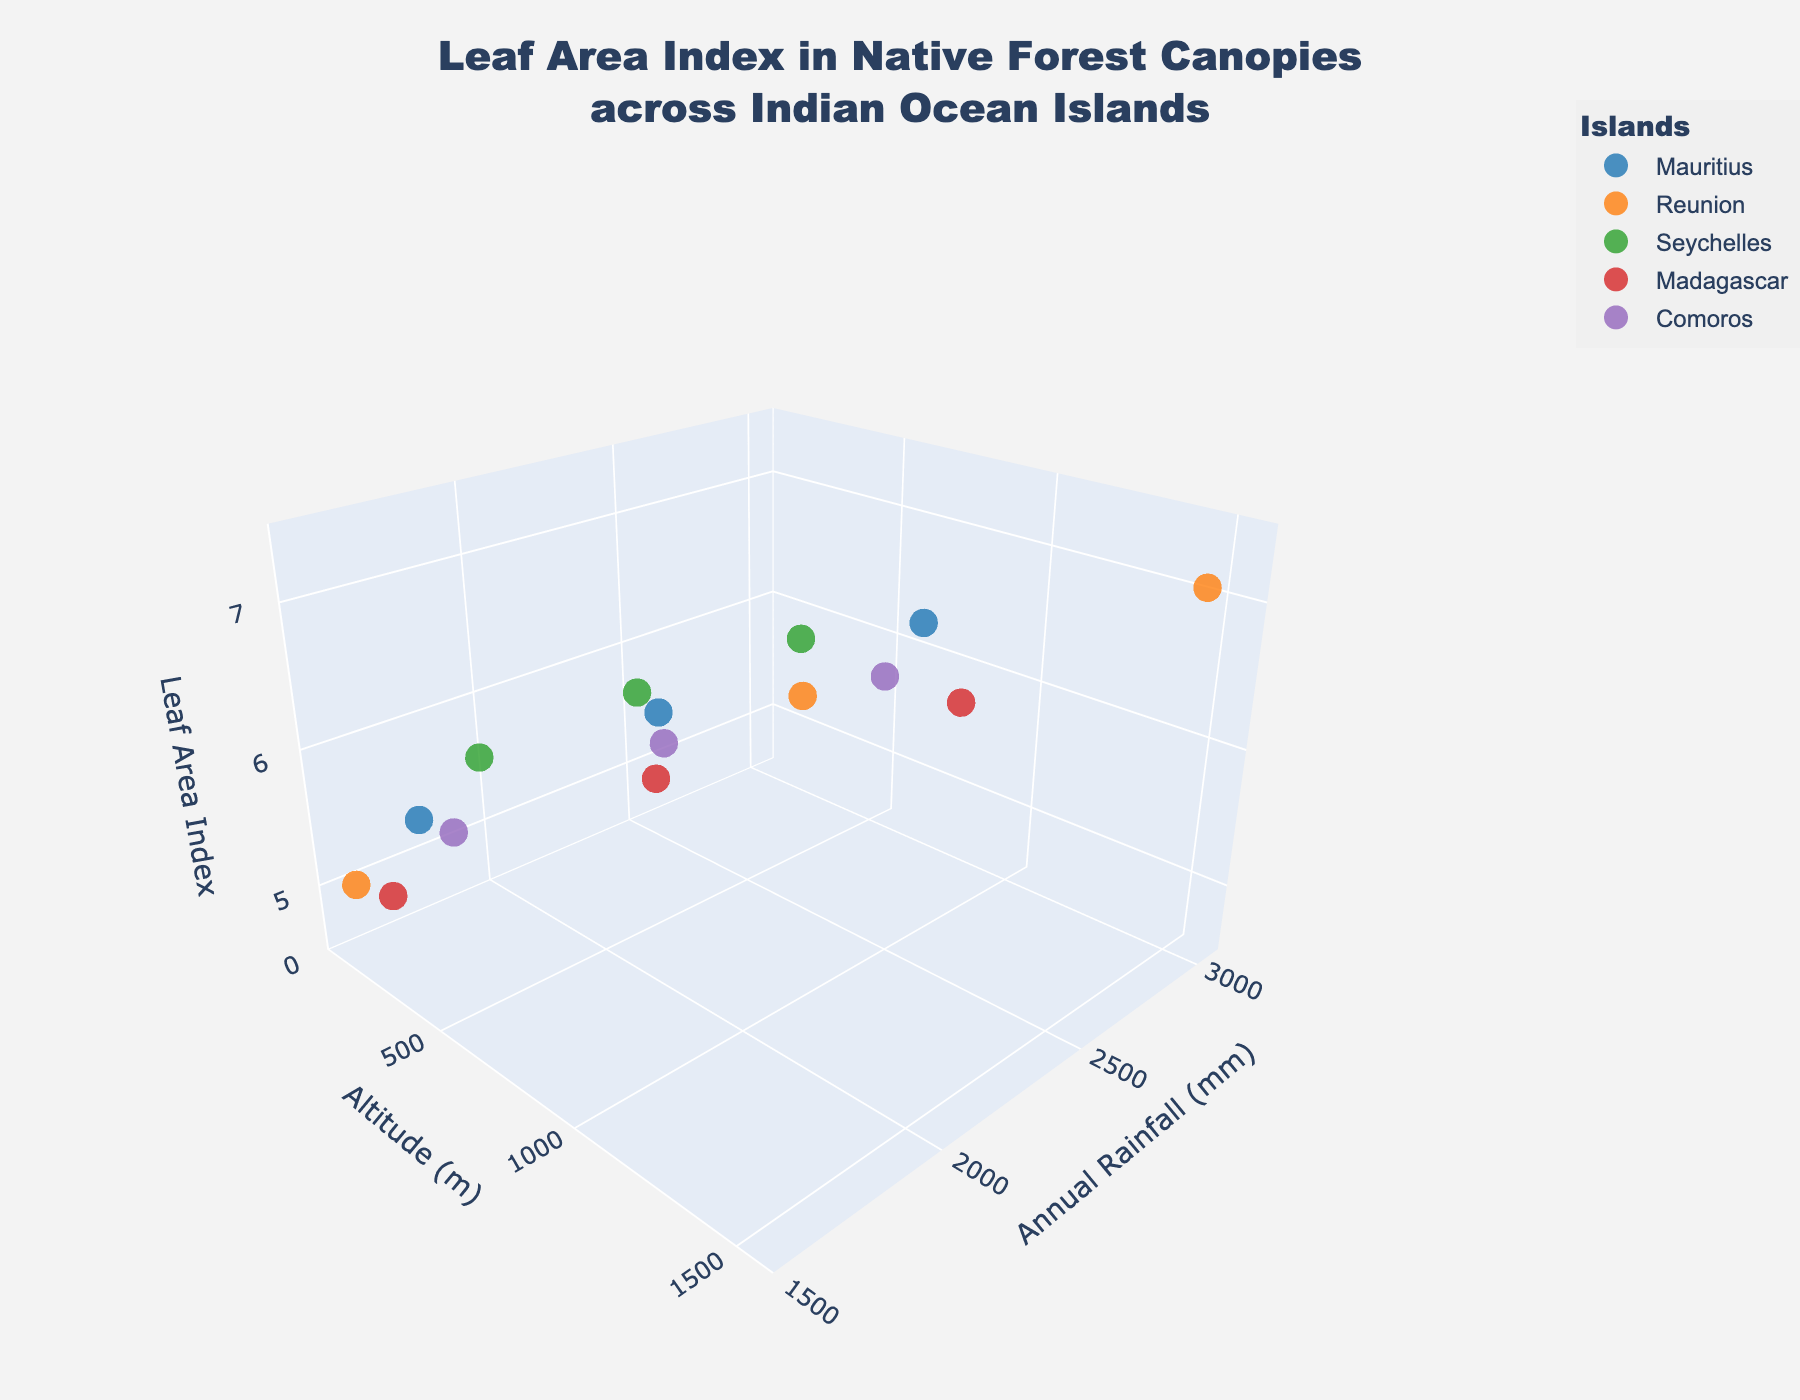What is the title of the figure? The title can be found at the top of the plot. It reads "Leaf Area Index in Native Forest Canopies across Indian Ocean Islands".
Answer: Leaf Area Index in Native Forest Canopies across Indian Ocean Islands How many islands are represented in the plot? By inspecting the legend, we can count the number of unique islands represented. The legend shows five islands: Mauritius, Reunion, Seychelles, Madagascar, and Comoros.
Answer: 5 Which island has the highest recorded Leaf Area Index? By looking at the Z-axis (Leaf Area Index) values and identifying the highest data point, we see that the highest Leaf Area Index is 7.1, and it is recorded for Reunion.
Answer: Reunion What is the Leaf Area Index for Mauritius at an altitude of 1000 meters and annual rainfall of 2600 mm? By pinpointing the coordinates on the 3D plot where Altitude is 1000 meters and Annual Rainfall is 2600 mm for Mauritius, we find the corresponding Leaf Area Index is 6.8.
Answer: 6.8 Which data point has the lowest Leaf Area Index and which island does it belong to? The lowest Leaf Area Index is identified as 4.7 by inspecting the Z-axis values, and according to the legend, it belongs to Madagascar.
Answer: 4.7, Madagascar How does Leaf Area Index tend to change with increasing altitude within the same island? By comparing data points for each island group, we generally see an increase in the Leaf Area Index with higher altitudes. For example, in Reunion the Leaf Area Index values are 4.9, 6.3, and 7.1 as altitude increases.
Answer: It generally increases For Seychelles, what is the approximate change in Leaf Area Index from 0 to 600 meters in altitude? For Seychelles, at 0 meters (2000 mm rainfall), the Leaf Area Index is 5.5, while at 600 meters (2600 mm rainfall), it's 6.4. The change is calculated as 6.4 - 5.5.
Answer: 0.9 Is there any island where the Leaf Area Index increases with both altitude and annual rainfall? By checking each island group, Reunion (and potentially others) shows increasing Leaf Area Index with both increased altitude and increased annual rainfall. For Reunion: 4.9 (0m, 1600mm), 6.3 (800m, 2400mm), 7.1 (1500m, 3000mm).
Answer: Yes, Reunion Which two islands have the most similar Leaf Area Index values at zero meters altitude? At zero meters, we compare Leaf Area Index values: Mauritius (5.2), Reunion (4.9), Seychelles (5.5), Madagascar (4.7), and Comoros (5.0). Mauritius and Seychelles are the closest with 5.2 and 5.5 respectively.
Answer: Mauritius and Seychelles Is there a trend between annual rainfall and Leaf Area Index across all islands? By analyzing data points across the 3D plot, there appears to be a general trend that higher Leaf Area Index values are associated with higher annual rainfall. For example, observe increasing Z-values with increasing Y-values within each island group.
Answer: Yes, increasing rainfall generally increases Leaf Area Index 